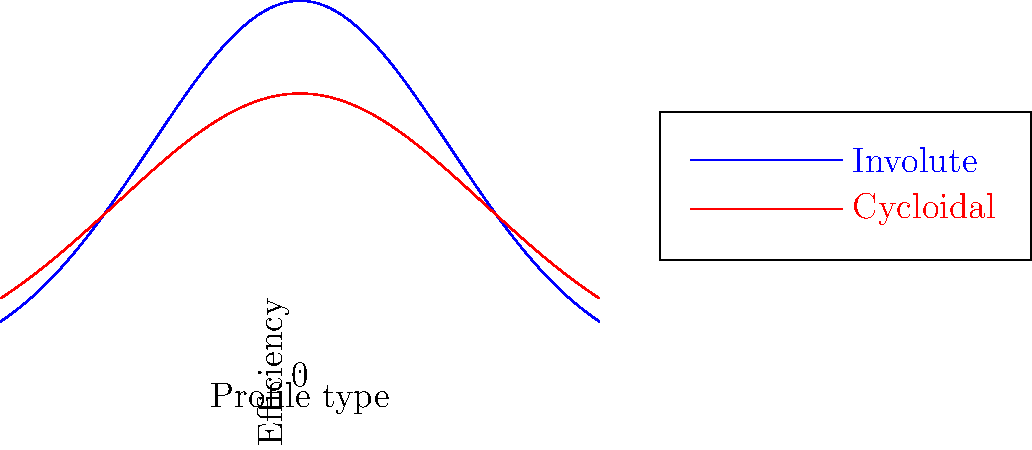As a marketing student promoting engineering products, you come across a graph comparing the efficiency of involute and cycloidal gear tooth profiles. Based on the graph, which gear tooth profile appears to have higher overall efficiency for power transmission? To answer this question, we need to analyze the graph:

1. The graph shows two curves: blue for involute profile and red for cycloidal profile.
2. The y-axis represents efficiency, while the x-axis represents different profile types or conditions.
3. We need to compare the overall height of the curves, as higher values on the y-axis indicate higher efficiency.
4. Observing the graph, we can see that:
   a. The blue curve (involute) reaches a higher peak efficiency than the red curve (cycloidal).
   b. The blue curve maintains higher efficiency values across a wider range of the x-axis.
5. Although the cycloidal profile (red curve) shows some efficiency, it is consistently lower than the involute profile.

Therefore, based on this graph, the involute gear tooth profile appears to have higher overall efficiency for power transmission.
Answer: Involute gear tooth profile 